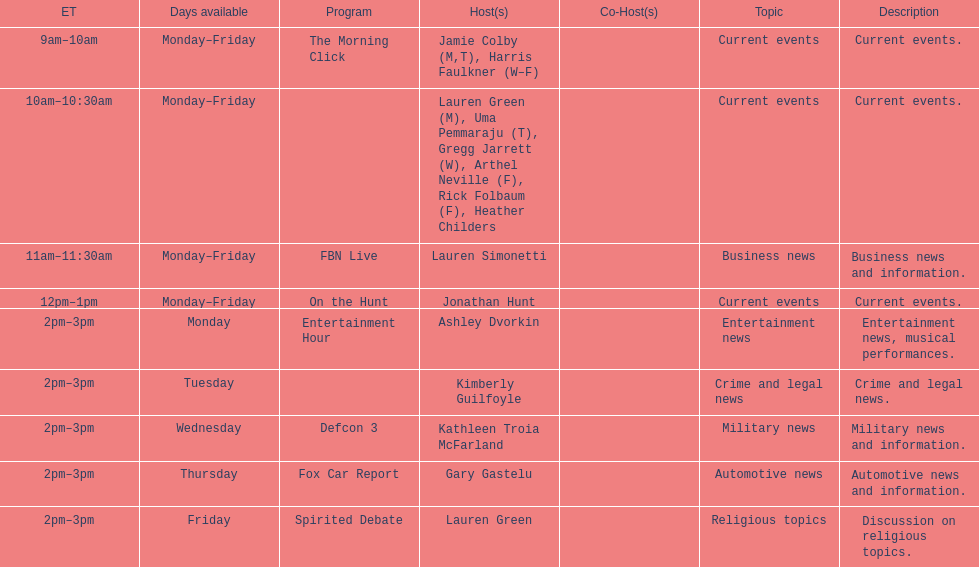How long does the show defcon 3 last? 1 hour. 